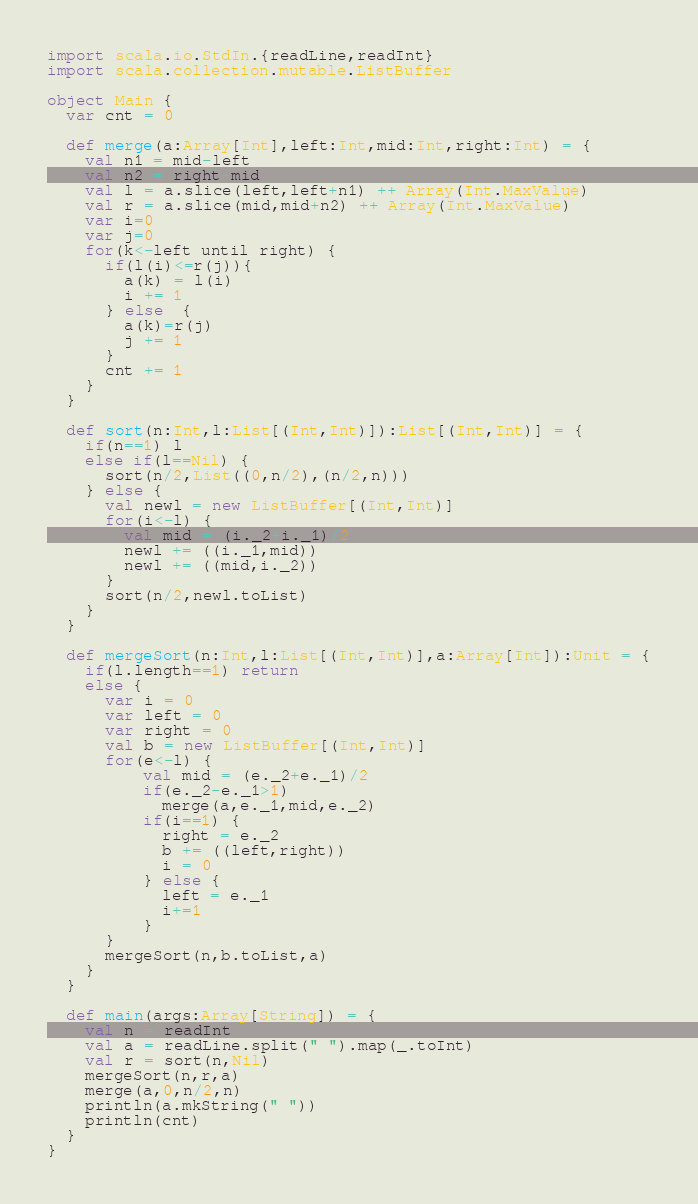<code> <loc_0><loc_0><loc_500><loc_500><_Scala_>import scala.io.StdIn.{readLine,readInt}
import scala.collection.mutable.ListBuffer

object Main {
  var cnt = 0

  def merge(a:Array[Int],left:Int,mid:Int,right:Int) = {
    val n1 = mid-left
    val n2 = right-mid
    val l = a.slice(left,left+n1) ++ Array(Int.MaxValue)
    val r = a.slice(mid,mid+n2) ++ Array(Int.MaxValue)
    var i=0
    var j=0
    for(k<-left until right) {
      if(l(i)<=r(j)){
        a(k) = l(i)
        i += 1
      } else  {
        a(k)=r(j)
        j += 1
      }
      cnt += 1
    }
  }

  def sort(n:Int,l:List[(Int,Int)]):List[(Int,Int)] = {
    if(n==1) l
    else if(l==Nil) {
      sort(n/2,List((0,n/2),(n/2,n)))
    } else {
      val newl = new ListBuffer[(Int,Int)]
      for(i<-l) {
        val mid = (i._2+i._1)/2
        newl += ((i._1,mid))
        newl += ((mid,i._2))
      }
      sort(n/2,newl.toList)
    }
  }

  def mergeSort(n:Int,l:List[(Int,Int)],a:Array[Int]):Unit = {
    if(l.length==1) return
    else {
      var i = 0
      var left = 0
      var right = 0
      val b = new ListBuffer[(Int,Int)]
      for(e<-l) {
          val mid = (e._2+e._1)/2
          if(e._2-e._1>1)
            merge(a,e._1,mid,e._2)
          if(i==1) {
            right = e._2
            b += ((left,right))
            i = 0
          } else {
            left = e._1
            i+=1
          }
      }
      mergeSort(n,b.toList,a)
    }
  }

  def main(args:Array[String]) = {
    val n = readInt
    val a = readLine.split(" ").map(_.toInt)
    val r = sort(n,Nil)
    mergeSort(n,r,a)
    merge(a,0,n/2,n)
    println(a.mkString(" "))
    println(cnt)
  }
}</code> 